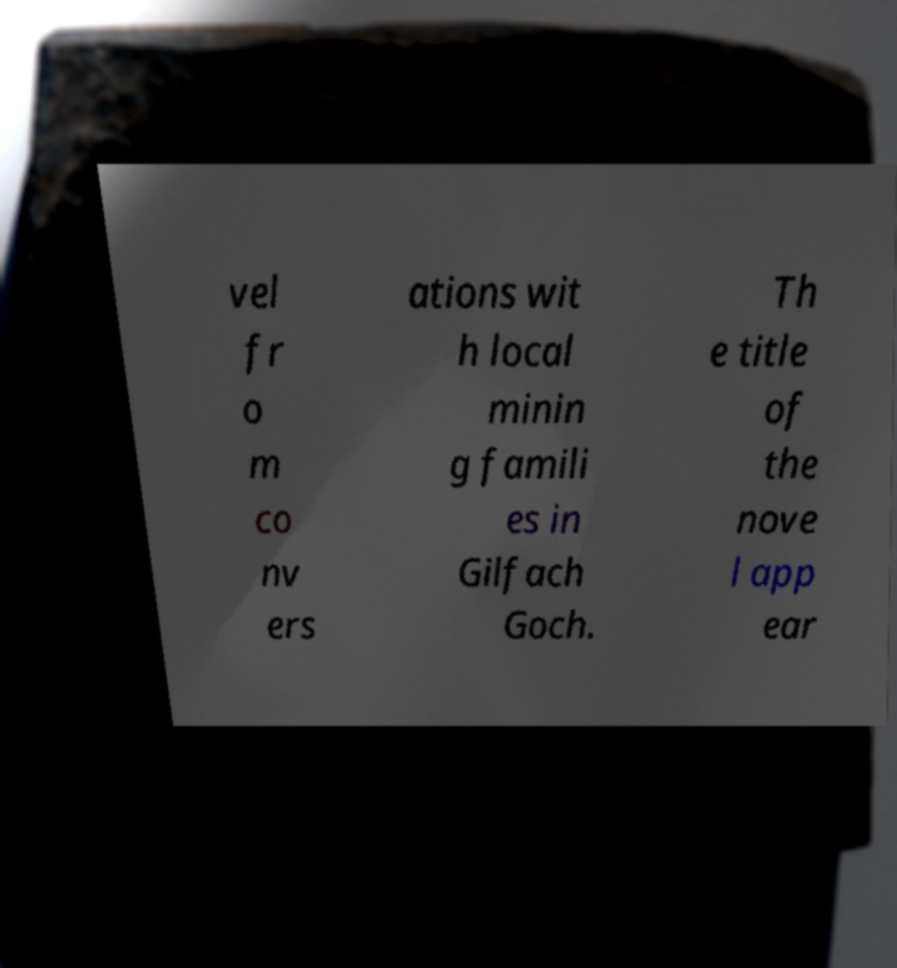Could you extract and type out the text from this image? vel fr o m co nv ers ations wit h local minin g famili es in Gilfach Goch. Th e title of the nove l app ear 